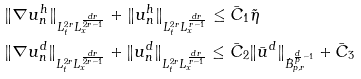Convert formula to latex. <formula><loc_0><loc_0><loc_500><loc_500>& \| \nabla u _ { n } ^ { h } \| _ { L ^ { 2 r } _ { t } L ^ { \frac { d r } { 2 r - 1 } } _ { x } } + \| u _ { n } ^ { h } \| _ { L ^ { 2 r } _ { t } L ^ { \frac { d r } { r - 1 } } _ { x } } \leq \bar { C } _ { 1 } \tilde { \eta } \\ & \| \nabla u _ { n } ^ { d } \| _ { L ^ { 2 r } _ { t } L ^ { \frac { d r } { 2 r - 1 } } _ { x } } + \| u _ { n } ^ { d } \| _ { L ^ { 2 r } _ { t } L ^ { \frac { d r } { r - 1 } } _ { x } } \leq \bar { C } _ { 2 } \| \bar { u } ^ { d } \| _ { \dot { B } _ { p , r } ^ { \frac { d } { p } - 1 } } + \bar { C } _ { 3 }</formula> 